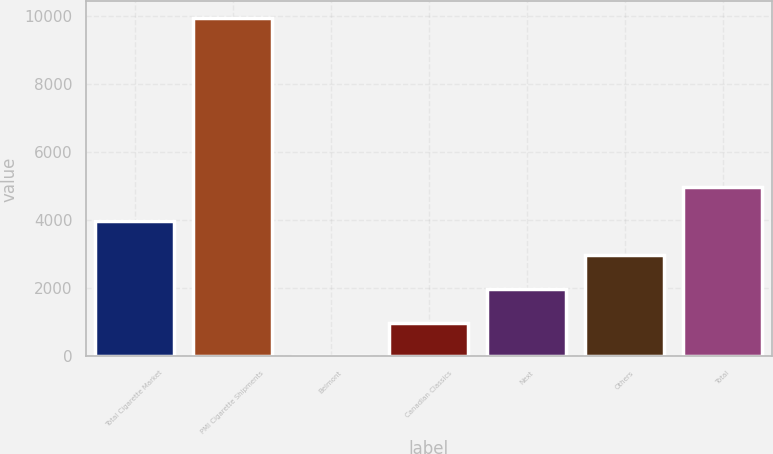Convert chart. <chart><loc_0><loc_0><loc_500><loc_500><bar_chart><fcel>Total Cigarette Market<fcel>PMI Cigarette Shipments<fcel>Belmont<fcel>Canadian Classics<fcel>Next<fcel>Others<fcel>Total<nl><fcel>3972.38<fcel>9926<fcel>3.3<fcel>995.57<fcel>1987.84<fcel>2980.11<fcel>4964.65<nl></chart> 